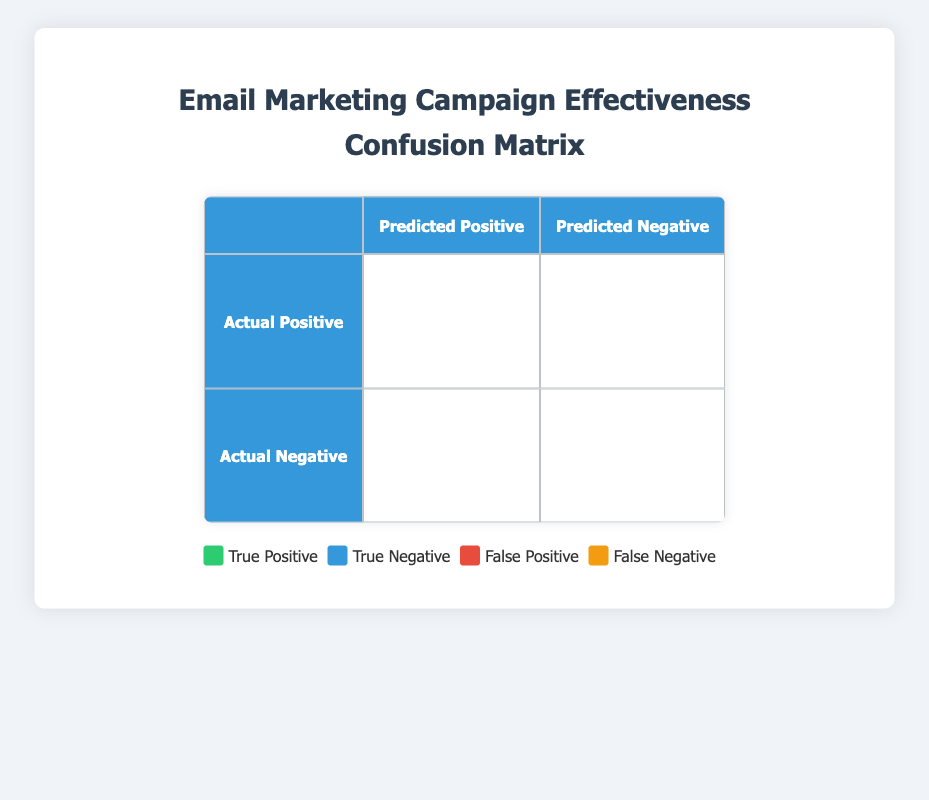What's the number of True Positives for Clicked? In the table, True Positives are represented in the first row under "Actual Positive" and the column "Predicted Positive." The value for Clicked is given as 95.
Answer: 95 What is the total number of False Negatives? To find the total number of False Negatives, we sum the values in the False Negative row: Not Opened (20) + Not Clicked (15) + Not Converted (5) = 40.
Answer: 40 Is the number of True Negatives for Not Opened greater than for Not Clicked? In the True Negative section, Not Opened has 150 while Not Clicked has 130. Thus, 150 is greater than 130, indicating that the statement is true.
Answer: Yes What is the difference between True Positives for Opened and False Positives for Opened? The value for True Positives under Opened is 120 and for False Positives is 30. The difference is calculated by subtracting: 120 - 30 = 90.
Answer: 90 What percentage of emails were Clicked out of the total Opened? The total number of Opened emails is 120 (True Positive) + 30 (False Positive) = 150. The number of Clicked emails is 95 (True Positive) + 20 (False Positive) = 115. The percentage is calculated as (115/150) * 100 = 76.67%.
Answer: 76.67% How many emails were neither Clicked nor Converted? We need to identify emails that fall under False Negatives (Not Clicked: 15) and True Negatives (Not Clicked: 130, Not Converted: 120). Summing these values: 15 + 130 + 120 = 265 emails were neither Clicked nor Converted.
Answer: 265 What is the total number of emails that were Converted? Conversions include True Positives (80) and not represented in the False Negatives (5 for Not Converted). Therefore, Total Converted = 80 (Converted) + 5 (Not Converted) = 85.
Answer: 85 How many emails were neither Opened nor Clicked? For this, we look at the True Negatives (Not Opened: 150) and False Positives (Not Clicked: 20). So the total: 150 (True Negative) + 20 (False Positive) = 170 emails were neither Opened nor Clicked.
Answer: 170 